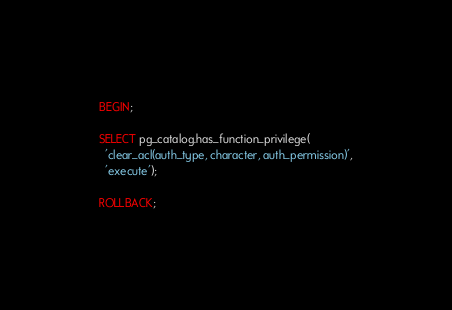<code> <loc_0><loc_0><loc_500><loc_500><_SQL_>BEGIN;

SELECT pg_catalog.has_function_privilege(
  'clear_acl(auth_type, character, auth_permission)',
  'execute');

ROLLBACK;
</code> 